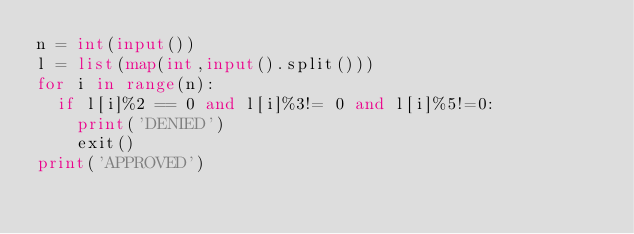<code> <loc_0><loc_0><loc_500><loc_500><_Python_>n = int(input())
l = list(map(int,input().split()))
for i in range(n):
  if l[i]%2 == 0 and l[i]%3!= 0 and l[i]%5!=0:
    print('DENIED')
    exit()
print('APPROVED')</code> 